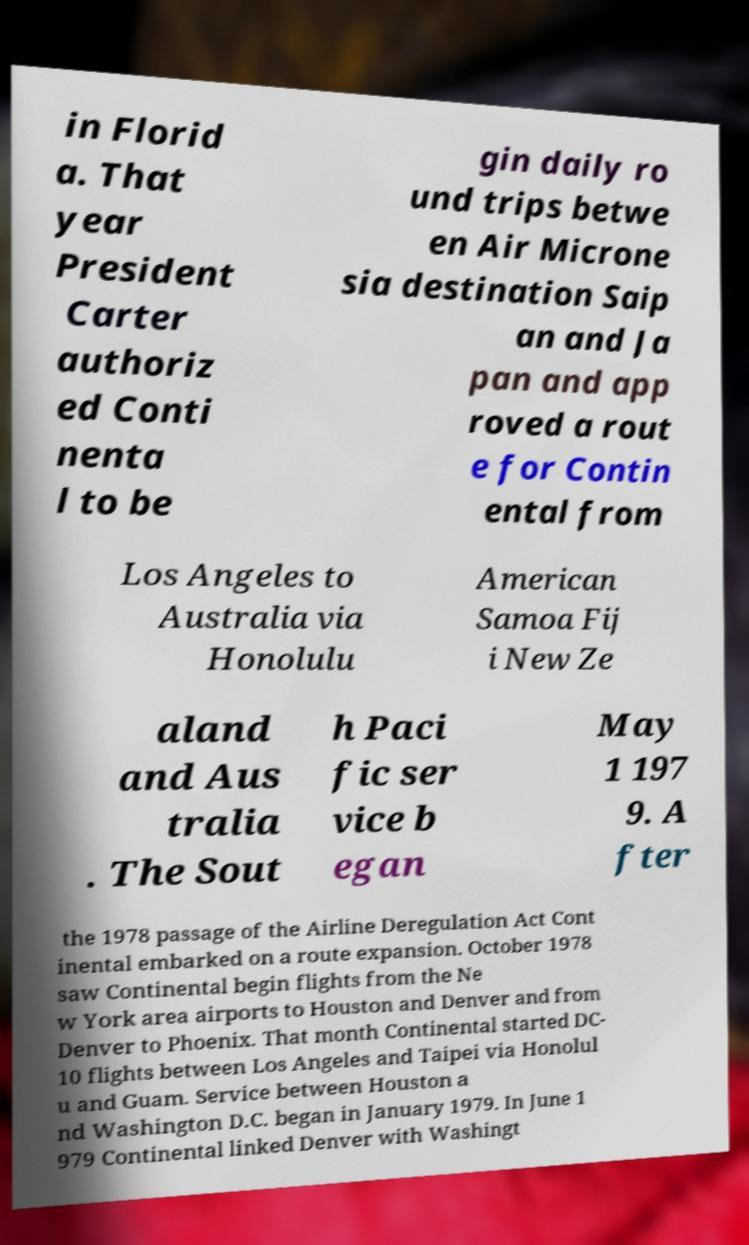Can you read and provide the text displayed in the image?This photo seems to have some interesting text. Can you extract and type it out for me? in Florid a. That year President Carter authoriz ed Conti nenta l to be gin daily ro und trips betwe en Air Microne sia destination Saip an and Ja pan and app roved a rout e for Contin ental from Los Angeles to Australia via Honolulu American Samoa Fij i New Ze aland and Aus tralia . The Sout h Paci fic ser vice b egan May 1 197 9. A fter the 1978 passage of the Airline Deregulation Act Cont inental embarked on a route expansion. October 1978 saw Continental begin flights from the Ne w York area airports to Houston and Denver and from Denver to Phoenix. That month Continental started DC- 10 flights between Los Angeles and Taipei via Honolul u and Guam. Service between Houston a nd Washington D.C. began in January 1979. In June 1 979 Continental linked Denver with Washingt 